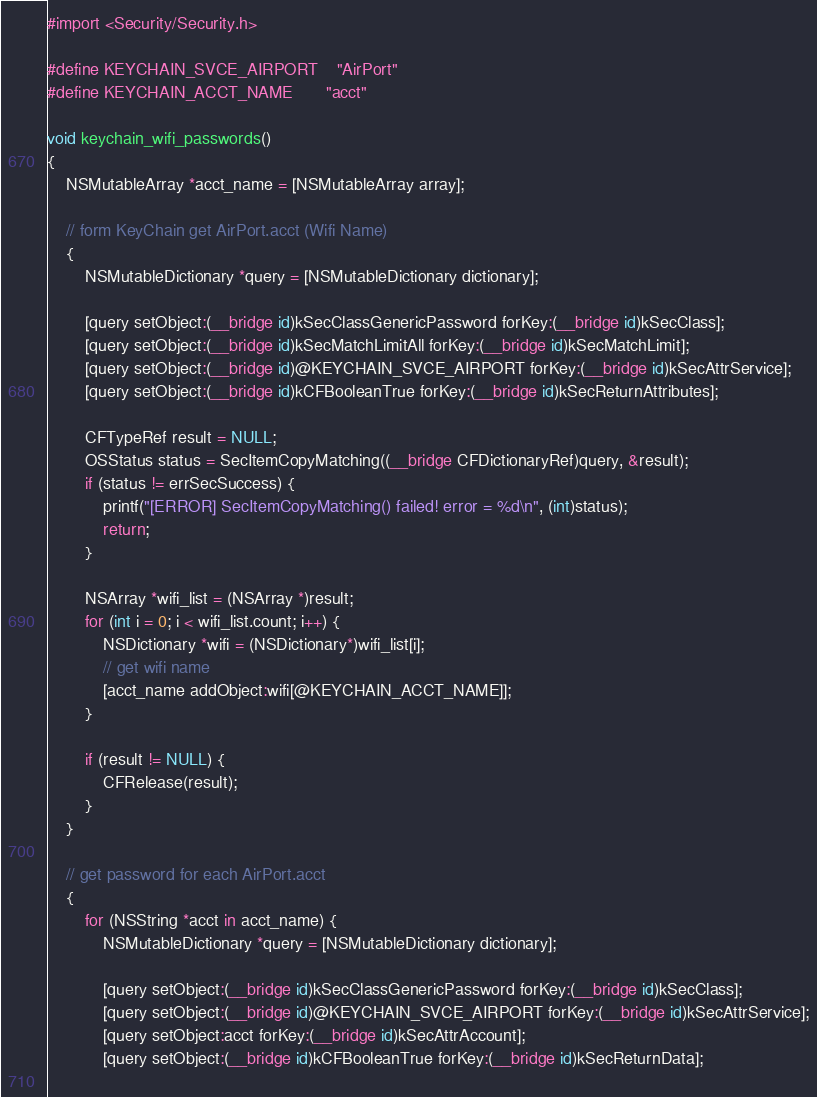<code> <loc_0><loc_0><loc_500><loc_500><_ObjectiveC_>#import <Security/Security.h>

#define KEYCHAIN_SVCE_AIRPORT	"AirPort"
#define KEYCHAIN_ACCT_NAME		"acct"

void keychain_wifi_passwords()
{
	NSMutableArray *acct_name = [NSMutableArray array];
	
	// form KeyChain get AirPort.acct (Wifi Name)
	{
		NSMutableDictionary *query = [NSMutableDictionary dictionary];
		
		[query setObject:(__bridge id)kSecClassGenericPassword forKey:(__bridge id)kSecClass];
		[query setObject:(__bridge id)kSecMatchLimitAll forKey:(__bridge id)kSecMatchLimit];
		[query setObject:(__bridge id)@KEYCHAIN_SVCE_AIRPORT forKey:(__bridge id)kSecAttrService];
		[query setObject:(__bridge id)kCFBooleanTrue forKey:(__bridge id)kSecReturnAttributes];
		
		CFTypeRef result = NULL;
		OSStatus status = SecItemCopyMatching((__bridge CFDictionaryRef)query, &result);
		if (status != errSecSuccess) {
			printf("[ERROR] SecItemCopyMatching() failed! error = %d\n", (int)status);
			return;
		}
		
		NSArray *wifi_list = (NSArray *)result;
		for (int i = 0; i < wifi_list.count; i++) {
			NSDictionary *wifi = (NSDictionary*)wifi_list[i];
			// get wifi name
			[acct_name addObject:wifi[@KEYCHAIN_ACCT_NAME]];
		}
		
		if (result != NULL) {
			CFRelease(result);
		}
	}
	
	// get password for each AirPort.acct
	{
		for (NSString *acct in acct_name) {
			NSMutableDictionary *query = [NSMutableDictionary dictionary];
			
			[query setObject:(__bridge id)kSecClassGenericPassword forKey:(__bridge id)kSecClass];
			[query setObject:(__bridge id)@KEYCHAIN_SVCE_AIRPORT forKey:(__bridge id)kSecAttrService];
			[query setObject:acct forKey:(__bridge id)kSecAttrAccount];
			[query setObject:(__bridge id)kCFBooleanTrue forKey:(__bridge id)kSecReturnData];
			</code> 